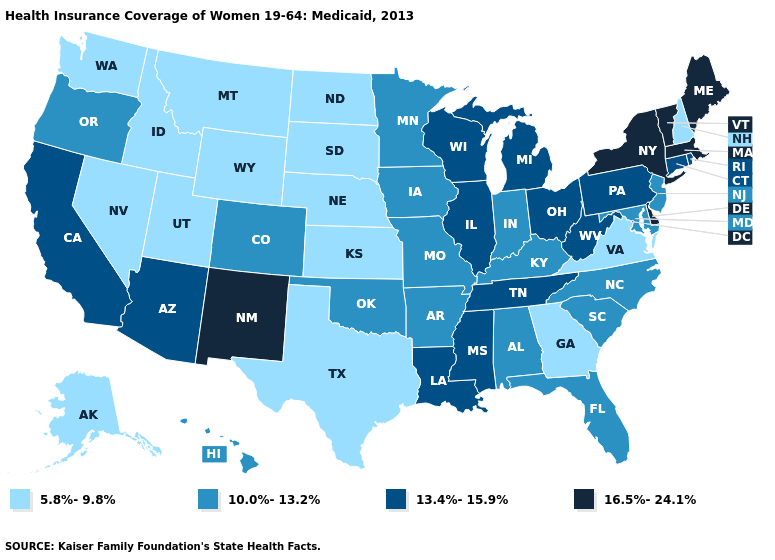Name the states that have a value in the range 13.4%-15.9%?
Give a very brief answer. Arizona, California, Connecticut, Illinois, Louisiana, Michigan, Mississippi, Ohio, Pennsylvania, Rhode Island, Tennessee, West Virginia, Wisconsin. Among the states that border North Carolina , does Tennessee have the highest value?
Quick response, please. Yes. Does the first symbol in the legend represent the smallest category?
Keep it brief. Yes. Which states have the lowest value in the MidWest?
Give a very brief answer. Kansas, Nebraska, North Dakota, South Dakota. Does Oregon have the same value as Illinois?
Quick response, please. No. Which states hav the highest value in the West?
Quick response, please. New Mexico. Name the states that have a value in the range 13.4%-15.9%?
Be succinct. Arizona, California, Connecticut, Illinois, Louisiana, Michigan, Mississippi, Ohio, Pennsylvania, Rhode Island, Tennessee, West Virginia, Wisconsin. What is the value of Florida?
Answer briefly. 10.0%-13.2%. What is the value of Kansas?
Concise answer only. 5.8%-9.8%. Does Vermont have a higher value than New Jersey?
Quick response, please. Yes. Does the map have missing data?
Short answer required. No. Which states hav the highest value in the MidWest?
Concise answer only. Illinois, Michigan, Ohio, Wisconsin. How many symbols are there in the legend?
Short answer required. 4. How many symbols are there in the legend?
Be succinct. 4. 